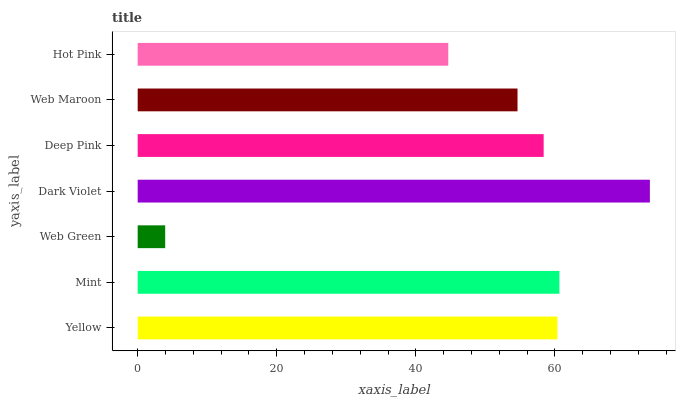Is Web Green the minimum?
Answer yes or no. Yes. Is Dark Violet the maximum?
Answer yes or no. Yes. Is Mint the minimum?
Answer yes or no. No. Is Mint the maximum?
Answer yes or no. No. Is Mint greater than Yellow?
Answer yes or no. Yes. Is Yellow less than Mint?
Answer yes or no. Yes. Is Yellow greater than Mint?
Answer yes or no. No. Is Mint less than Yellow?
Answer yes or no. No. Is Deep Pink the high median?
Answer yes or no. Yes. Is Deep Pink the low median?
Answer yes or no. Yes. Is Web Green the high median?
Answer yes or no. No. Is Mint the low median?
Answer yes or no. No. 